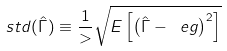Convert formula to latex. <formula><loc_0><loc_0><loc_500><loc_500>s t d ( \hat { \Gamma } ) \equiv \frac { 1 } { > } \sqrt { E \left [ \left ( \hat { \Gamma } - \ e g \right ) ^ { 2 } \right ] }</formula> 